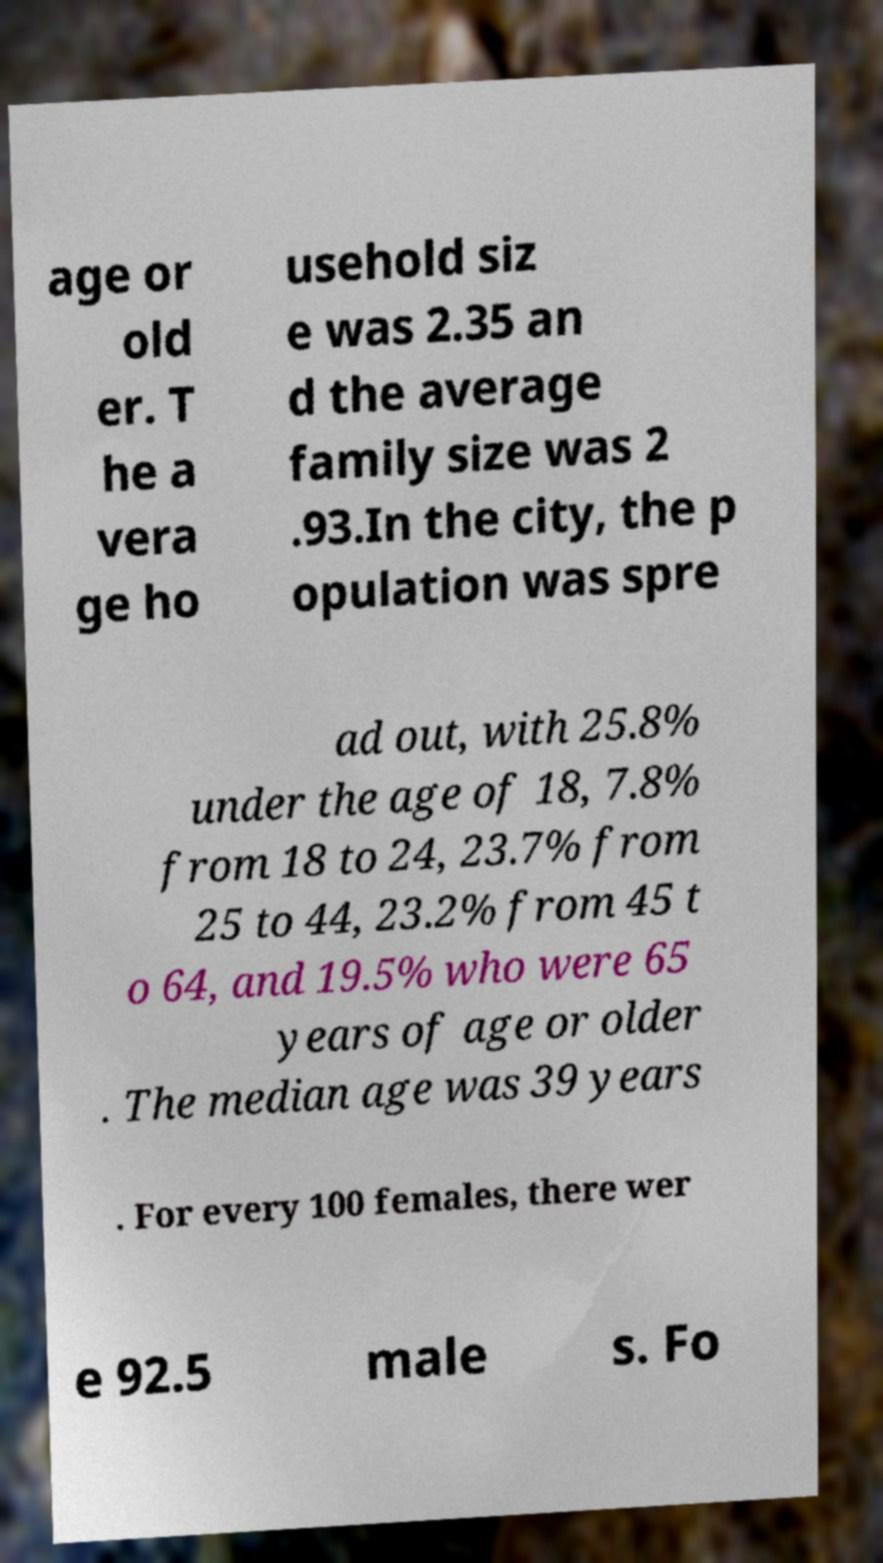There's text embedded in this image that I need extracted. Can you transcribe it verbatim? age or old er. T he a vera ge ho usehold siz e was 2.35 an d the average family size was 2 .93.In the city, the p opulation was spre ad out, with 25.8% under the age of 18, 7.8% from 18 to 24, 23.7% from 25 to 44, 23.2% from 45 t o 64, and 19.5% who were 65 years of age or older . The median age was 39 years . For every 100 females, there wer e 92.5 male s. Fo 